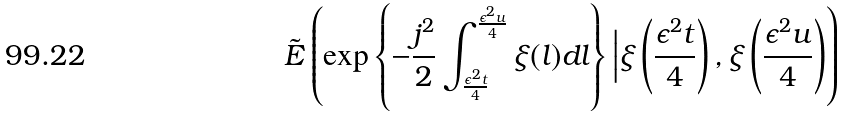<formula> <loc_0><loc_0><loc_500><loc_500>\tilde { E } \left ( \exp \left \{ - \frac { j ^ { 2 } } { 2 } \int ^ { \frac { \epsilon ^ { 2 } u } { 4 } } _ { \frac { \epsilon ^ { 2 } t } { 4 } } \xi ( l ) d l \right \} \Big | \xi \left ( \frac { \epsilon ^ { 2 } t } { 4 } \right ) , \xi \left ( \frac { \epsilon ^ { 2 } u } { 4 } \right ) \right )</formula> 